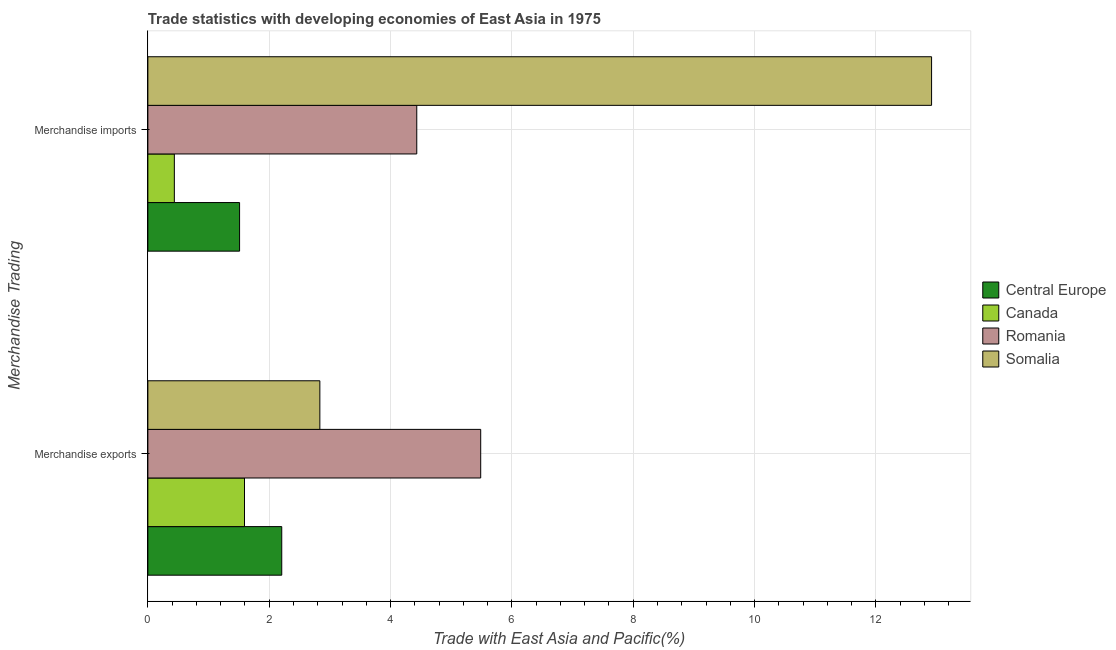Are the number of bars per tick equal to the number of legend labels?
Your answer should be very brief. Yes. Are the number of bars on each tick of the Y-axis equal?
Ensure brevity in your answer.  Yes. What is the merchandise exports in Somalia?
Offer a very short reply. 2.83. Across all countries, what is the maximum merchandise imports?
Your answer should be very brief. 12.92. Across all countries, what is the minimum merchandise imports?
Offer a very short reply. 0.44. In which country was the merchandise exports maximum?
Ensure brevity in your answer.  Romania. In which country was the merchandise imports minimum?
Give a very brief answer. Canada. What is the total merchandise imports in the graph?
Your answer should be very brief. 19.3. What is the difference between the merchandise exports in Canada and that in Romania?
Offer a very short reply. -3.89. What is the difference between the merchandise imports in Romania and the merchandise exports in Canada?
Give a very brief answer. 2.84. What is the average merchandise exports per country?
Give a very brief answer. 3.03. What is the difference between the merchandise imports and merchandise exports in Canada?
Make the answer very short. -1.16. What is the ratio of the merchandise exports in Canada to that in Central Europe?
Offer a very short reply. 0.72. In how many countries, is the merchandise imports greater than the average merchandise imports taken over all countries?
Ensure brevity in your answer.  1. What does the 1st bar from the top in Merchandise imports represents?
Your answer should be compact. Somalia. How many bars are there?
Give a very brief answer. 8. Where does the legend appear in the graph?
Offer a very short reply. Center right. How are the legend labels stacked?
Give a very brief answer. Vertical. What is the title of the graph?
Offer a very short reply. Trade statistics with developing economies of East Asia in 1975. What is the label or title of the X-axis?
Your answer should be compact. Trade with East Asia and Pacific(%). What is the label or title of the Y-axis?
Offer a very short reply. Merchandise Trading. What is the Trade with East Asia and Pacific(%) in Central Europe in Merchandise exports?
Ensure brevity in your answer.  2.21. What is the Trade with East Asia and Pacific(%) of Canada in Merchandise exports?
Give a very brief answer. 1.59. What is the Trade with East Asia and Pacific(%) of Romania in Merchandise exports?
Make the answer very short. 5.49. What is the Trade with East Asia and Pacific(%) in Somalia in Merchandise exports?
Offer a very short reply. 2.83. What is the Trade with East Asia and Pacific(%) of Central Europe in Merchandise imports?
Your answer should be very brief. 1.51. What is the Trade with East Asia and Pacific(%) in Canada in Merchandise imports?
Give a very brief answer. 0.44. What is the Trade with East Asia and Pacific(%) in Romania in Merchandise imports?
Provide a short and direct response. 4.43. What is the Trade with East Asia and Pacific(%) in Somalia in Merchandise imports?
Give a very brief answer. 12.92. Across all Merchandise Trading, what is the maximum Trade with East Asia and Pacific(%) of Central Europe?
Give a very brief answer. 2.21. Across all Merchandise Trading, what is the maximum Trade with East Asia and Pacific(%) of Canada?
Your answer should be compact. 1.59. Across all Merchandise Trading, what is the maximum Trade with East Asia and Pacific(%) in Romania?
Keep it short and to the point. 5.49. Across all Merchandise Trading, what is the maximum Trade with East Asia and Pacific(%) in Somalia?
Make the answer very short. 12.92. Across all Merchandise Trading, what is the minimum Trade with East Asia and Pacific(%) of Central Europe?
Your answer should be very brief. 1.51. Across all Merchandise Trading, what is the minimum Trade with East Asia and Pacific(%) in Canada?
Give a very brief answer. 0.44. Across all Merchandise Trading, what is the minimum Trade with East Asia and Pacific(%) of Romania?
Provide a short and direct response. 4.43. Across all Merchandise Trading, what is the minimum Trade with East Asia and Pacific(%) of Somalia?
Give a very brief answer. 2.83. What is the total Trade with East Asia and Pacific(%) in Central Europe in the graph?
Your answer should be compact. 3.72. What is the total Trade with East Asia and Pacific(%) in Canada in the graph?
Give a very brief answer. 2.03. What is the total Trade with East Asia and Pacific(%) of Romania in the graph?
Offer a terse response. 9.92. What is the total Trade with East Asia and Pacific(%) in Somalia in the graph?
Your answer should be compact. 15.75. What is the difference between the Trade with East Asia and Pacific(%) of Central Europe in Merchandise exports and that in Merchandise imports?
Ensure brevity in your answer.  0.7. What is the difference between the Trade with East Asia and Pacific(%) of Canada in Merchandise exports and that in Merchandise imports?
Provide a succinct answer. 1.16. What is the difference between the Trade with East Asia and Pacific(%) in Romania in Merchandise exports and that in Merchandise imports?
Provide a short and direct response. 1.05. What is the difference between the Trade with East Asia and Pacific(%) of Somalia in Merchandise exports and that in Merchandise imports?
Ensure brevity in your answer.  -10.08. What is the difference between the Trade with East Asia and Pacific(%) of Central Europe in Merchandise exports and the Trade with East Asia and Pacific(%) of Canada in Merchandise imports?
Offer a very short reply. 1.77. What is the difference between the Trade with East Asia and Pacific(%) in Central Europe in Merchandise exports and the Trade with East Asia and Pacific(%) in Romania in Merchandise imports?
Offer a very short reply. -2.23. What is the difference between the Trade with East Asia and Pacific(%) in Central Europe in Merchandise exports and the Trade with East Asia and Pacific(%) in Somalia in Merchandise imports?
Your answer should be very brief. -10.71. What is the difference between the Trade with East Asia and Pacific(%) of Canada in Merchandise exports and the Trade with East Asia and Pacific(%) of Romania in Merchandise imports?
Provide a succinct answer. -2.84. What is the difference between the Trade with East Asia and Pacific(%) in Canada in Merchandise exports and the Trade with East Asia and Pacific(%) in Somalia in Merchandise imports?
Keep it short and to the point. -11.32. What is the difference between the Trade with East Asia and Pacific(%) in Romania in Merchandise exports and the Trade with East Asia and Pacific(%) in Somalia in Merchandise imports?
Provide a short and direct response. -7.43. What is the average Trade with East Asia and Pacific(%) of Central Europe per Merchandise Trading?
Your answer should be very brief. 1.86. What is the average Trade with East Asia and Pacific(%) in Canada per Merchandise Trading?
Your answer should be compact. 1.01. What is the average Trade with East Asia and Pacific(%) of Romania per Merchandise Trading?
Offer a very short reply. 4.96. What is the average Trade with East Asia and Pacific(%) in Somalia per Merchandise Trading?
Offer a very short reply. 7.88. What is the difference between the Trade with East Asia and Pacific(%) of Central Europe and Trade with East Asia and Pacific(%) of Canada in Merchandise exports?
Give a very brief answer. 0.61. What is the difference between the Trade with East Asia and Pacific(%) in Central Europe and Trade with East Asia and Pacific(%) in Romania in Merchandise exports?
Provide a short and direct response. -3.28. What is the difference between the Trade with East Asia and Pacific(%) of Central Europe and Trade with East Asia and Pacific(%) of Somalia in Merchandise exports?
Offer a very short reply. -0.63. What is the difference between the Trade with East Asia and Pacific(%) in Canada and Trade with East Asia and Pacific(%) in Romania in Merchandise exports?
Your answer should be very brief. -3.89. What is the difference between the Trade with East Asia and Pacific(%) of Canada and Trade with East Asia and Pacific(%) of Somalia in Merchandise exports?
Provide a short and direct response. -1.24. What is the difference between the Trade with East Asia and Pacific(%) in Romania and Trade with East Asia and Pacific(%) in Somalia in Merchandise exports?
Provide a succinct answer. 2.65. What is the difference between the Trade with East Asia and Pacific(%) in Central Europe and Trade with East Asia and Pacific(%) in Canada in Merchandise imports?
Ensure brevity in your answer.  1.07. What is the difference between the Trade with East Asia and Pacific(%) in Central Europe and Trade with East Asia and Pacific(%) in Romania in Merchandise imports?
Your answer should be compact. -2.92. What is the difference between the Trade with East Asia and Pacific(%) of Central Europe and Trade with East Asia and Pacific(%) of Somalia in Merchandise imports?
Your response must be concise. -11.41. What is the difference between the Trade with East Asia and Pacific(%) of Canada and Trade with East Asia and Pacific(%) of Romania in Merchandise imports?
Your response must be concise. -4. What is the difference between the Trade with East Asia and Pacific(%) of Canada and Trade with East Asia and Pacific(%) of Somalia in Merchandise imports?
Your response must be concise. -12.48. What is the difference between the Trade with East Asia and Pacific(%) in Romania and Trade with East Asia and Pacific(%) in Somalia in Merchandise imports?
Provide a short and direct response. -8.48. What is the ratio of the Trade with East Asia and Pacific(%) in Central Europe in Merchandise exports to that in Merchandise imports?
Ensure brevity in your answer.  1.46. What is the ratio of the Trade with East Asia and Pacific(%) in Canada in Merchandise exports to that in Merchandise imports?
Provide a short and direct response. 3.65. What is the ratio of the Trade with East Asia and Pacific(%) of Romania in Merchandise exports to that in Merchandise imports?
Offer a very short reply. 1.24. What is the ratio of the Trade with East Asia and Pacific(%) in Somalia in Merchandise exports to that in Merchandise imports?
Make the answer very short. 0.22. What is the difference between the highest and the second highest Trade with East Asia and Pacific(%) of Central Europe?
Provide a succinct answer. 0.7. What is the difference between the highest and the second highest Trade with East Asia and Pacific(%) of Canada?
Make the answer very short. 1.16. What is the difference between the highest and the second highest Trade with East Asia and Pacific(%) in Romania?
Keep it short and to the point. 1.05. What is the difference between the highest and the second highest Trade with East Asia and Pacific(%) in Somalia?
Give a very brief answer. 10.08. What is the difference between the highest and the lowest Trade with East Asia and Pacific(%) of Central Europe?
Your answer should be compact. 0.7. What is the difference between the highest and the lowest Trade with East Asia and Pacific(%) in Canada?
Your answer should be very brief. 1.16. What is the difference between the highest and the lowest Trade with East Asia and Pacific(%) of Romania?
Provide a short and direct response. 1.05. What is the difference between the highest and the lowest Trade with East Asia and Pacific(%) of Somalia?
Provide a short and direct response. 10.08. 